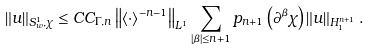<formula> <loc_0><loc_0><loc_500><loc_500>\left \| u \right \| _ { S _ { w } ^ { 1 } , \chi } \leq C C _ { \Gamma , n } \left \| \left \langle \cdot \right \rangle ^ { - n - 1 } \right \| _ { L ^ { 1 } } \sum _ { \left | \beta \right | \leq n + 1 } p _ { n + 1 } \left ( \partial ^ { \beta } \chi \right ) \left \| u \right \| _ { H _ { 1 } ^ { n + 1 } } .</formula> 